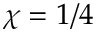Convert formula to latex. <formula><loc_0><loc_0><loc_500><loc_500>\chi = 1 / 4</formula> 